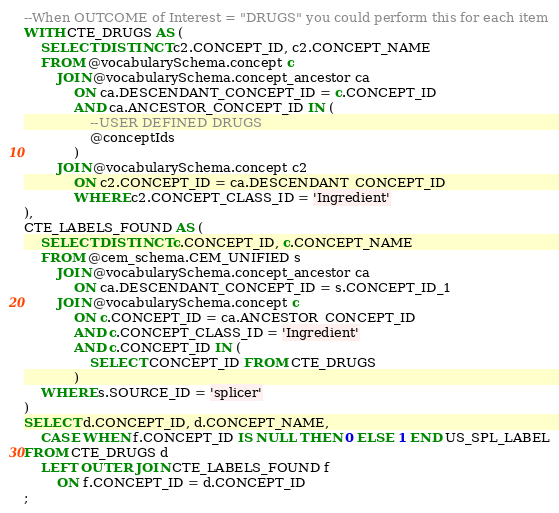Convert code to text. <code><loc_0><loc_0><loc_500><loc_500><_SQL_>--When OUTCOME of Interest = "DRUGS" you could perform this for each item
WITH CTE_DRUGS AS (
	SELECT DISTINCT c2.CONCEPT_ID, c2.CONCEPT_NAME
	FROM @vocabularySchema.concept c
		JOIN @vocabularySchema.concept_ancestor ca
			ON ca.DESCENDANT_CONCEPT_ID = c.CONCEPT_ID
			AND ca.ANCESTOR_CONCEPT_ID IN (
				--USER DEFINED DRUGS
				@conceptIds
			)
		JOIN @vocabularySchema.concept c2
			ON c2.CONCEPT_ID = ca.DESCENDANT_CONCEPT_ID
			WHERE c2.CONCEPT_CLASS_ID = 'Ingredient'
), 
CTE_LABELS_FOUND AS (
	SELECT DISTINCT c.CONCEPT_ID, c.CONCEPT_NAME
	FROM @cem_schema.CEM_UNIFIED s
		JOIN @vocabularySchema.concept_ancestor ca
			ON ca.DESCENDANT_CONCEPT_ID = s.CONCEPT_ID_1
		JOIN @vocabularySchema.concept c
			ON c.CONCEPT_ID = ca.ANCESTOR_CONCEPT_ID
			AND c.CONCEPT_CLASS_ID = 'Ingredient'
			AND c.CONCEPT_ID IN (
				SELECT CONCEPT_ID FROM CTE_DRUGS
			)
	WHERE s.SOURCE_ID = 'splicer' 
)
SELECT d.CONCEPT_ID, d.CONCEPT_NAME,
	CASE WHEN f.CONCEPT_ID IS NULL THEN 0 ELSE 1 END US_SPL_LABEL
FROM CTE_DRUGS d
	LEFT OUTER JOIN CTE_LABELS_FOUND f
		ON f.CONCEPT_ID = d.CONCEPT_ID
;
</code> 